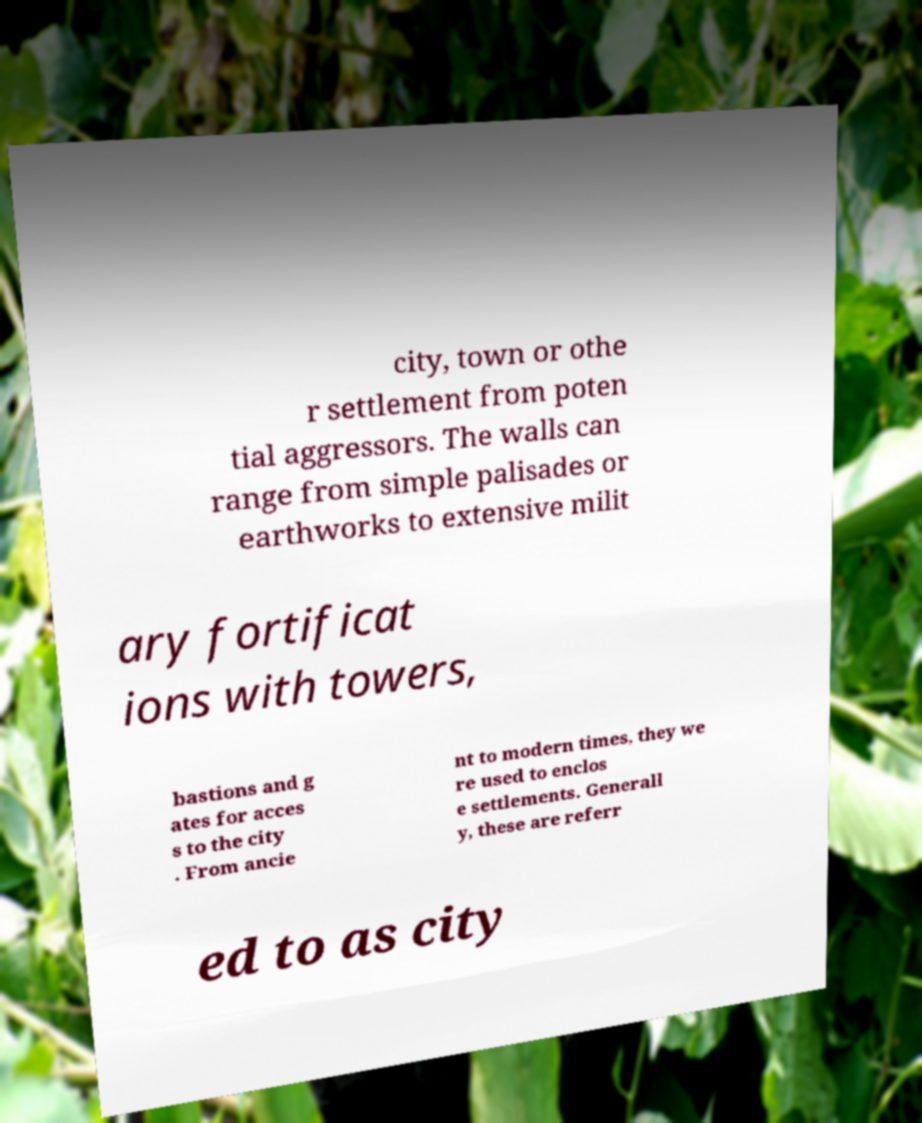Can you accurately transcribe the text from the provided image for me? city, town or othe r settlement from poten tial aggressors. The walls can range from simple palisades or earthworks to extensive milit ary fortificat ions with towers, bastions and g ates for acces s to the city . From ancie nt to modern times, they we re used to enclos e settlements. Generall y, these are referr ed to as city 